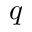<formula> <loc_0><loc_0><loc_500><loc_500>{ q }</formula> 